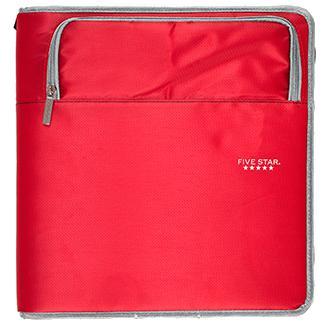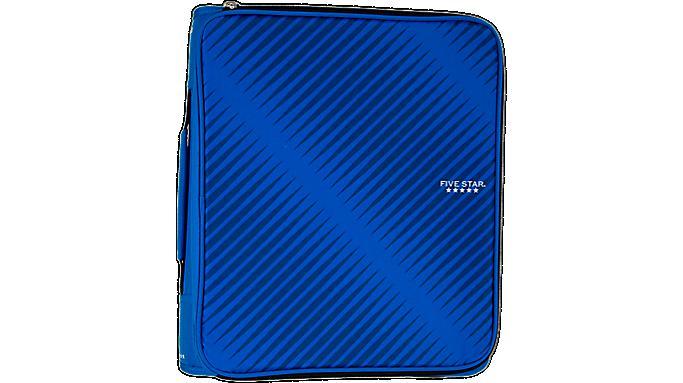The first image is the image on the left, the second image is the image on the right. Examine the images to the left and right. Is the description "The case in one of the images is blue." accurate? Answer yes or no. Yes. 